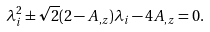<formula> <loc_0><loc_0><loc_500><loc_500>\lambda _ { i } ^ { 2 } \pm \sqrt { 2 } ( 2 - A _ { , z } ) \lambda _ { i } - 4 A _ { , z } = 0 .</formula> 